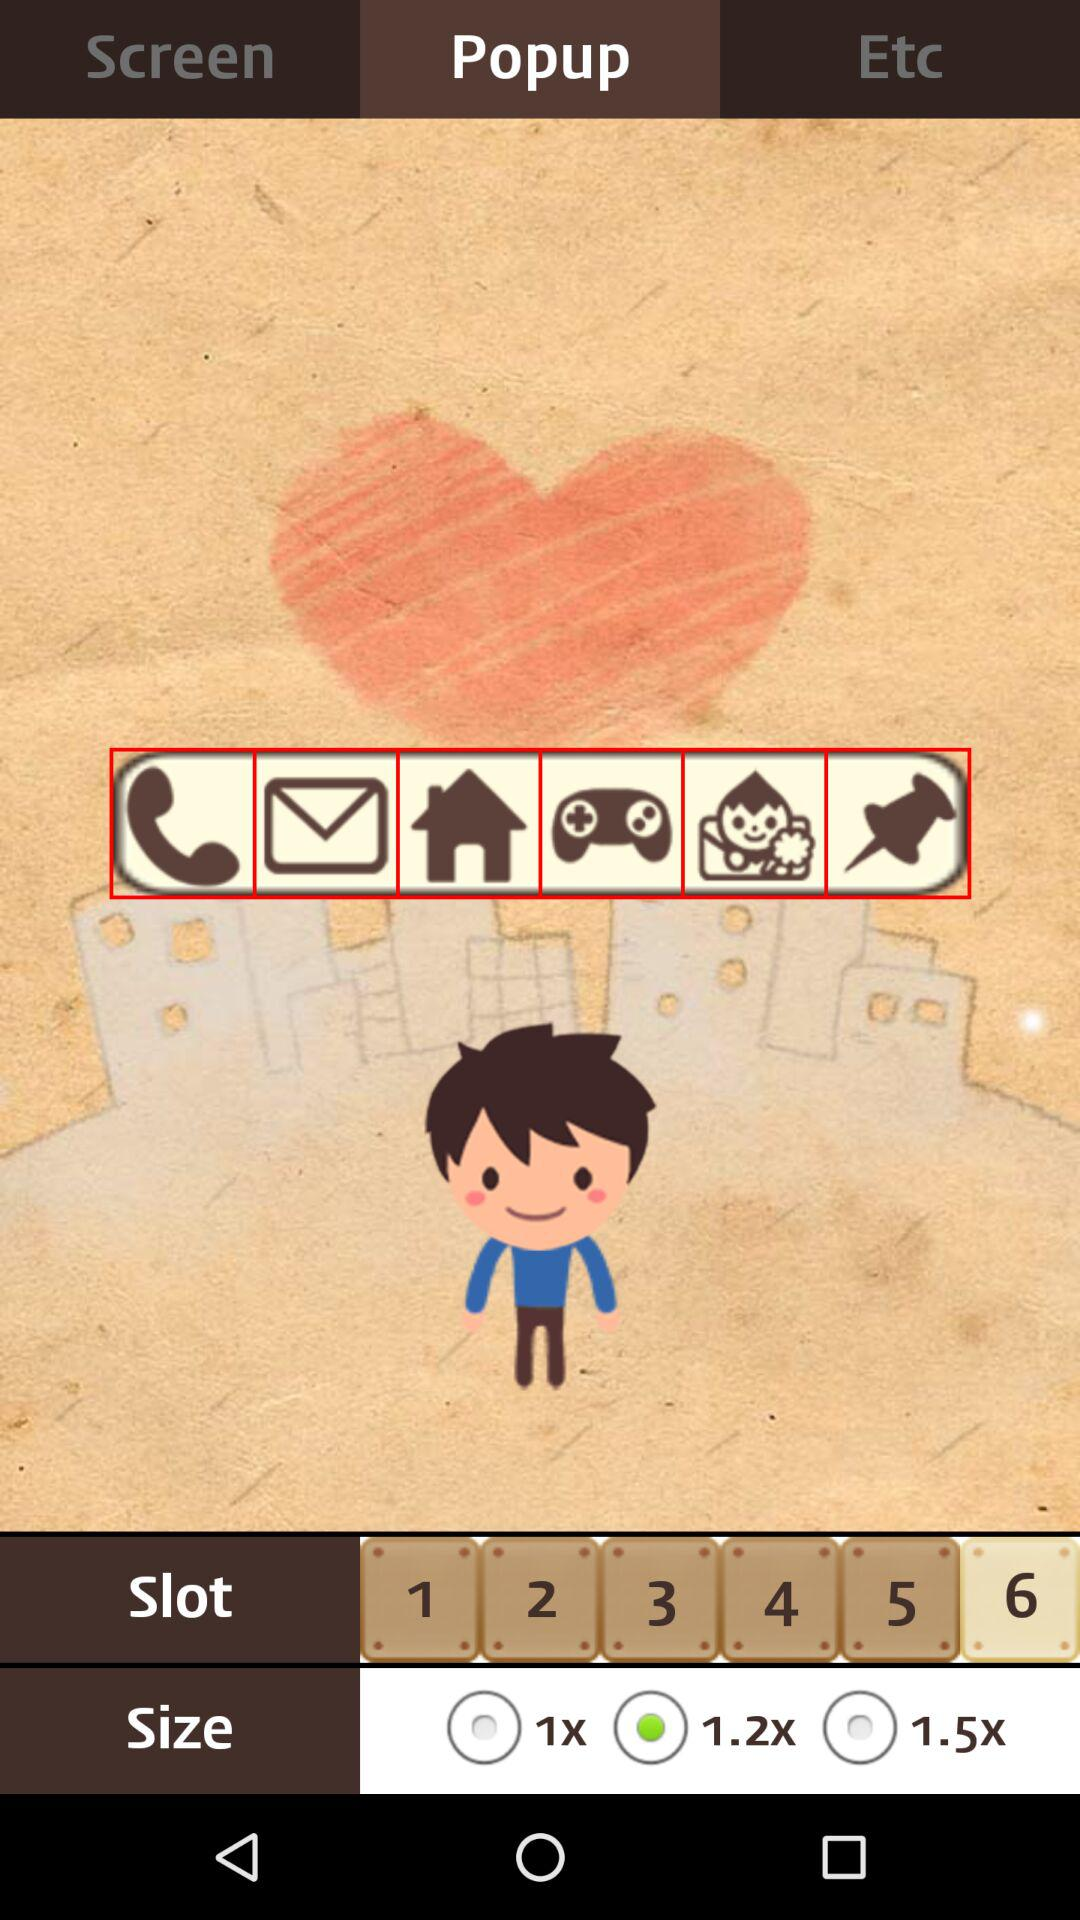Which size is chosen? The chosen size is "1.2x". 